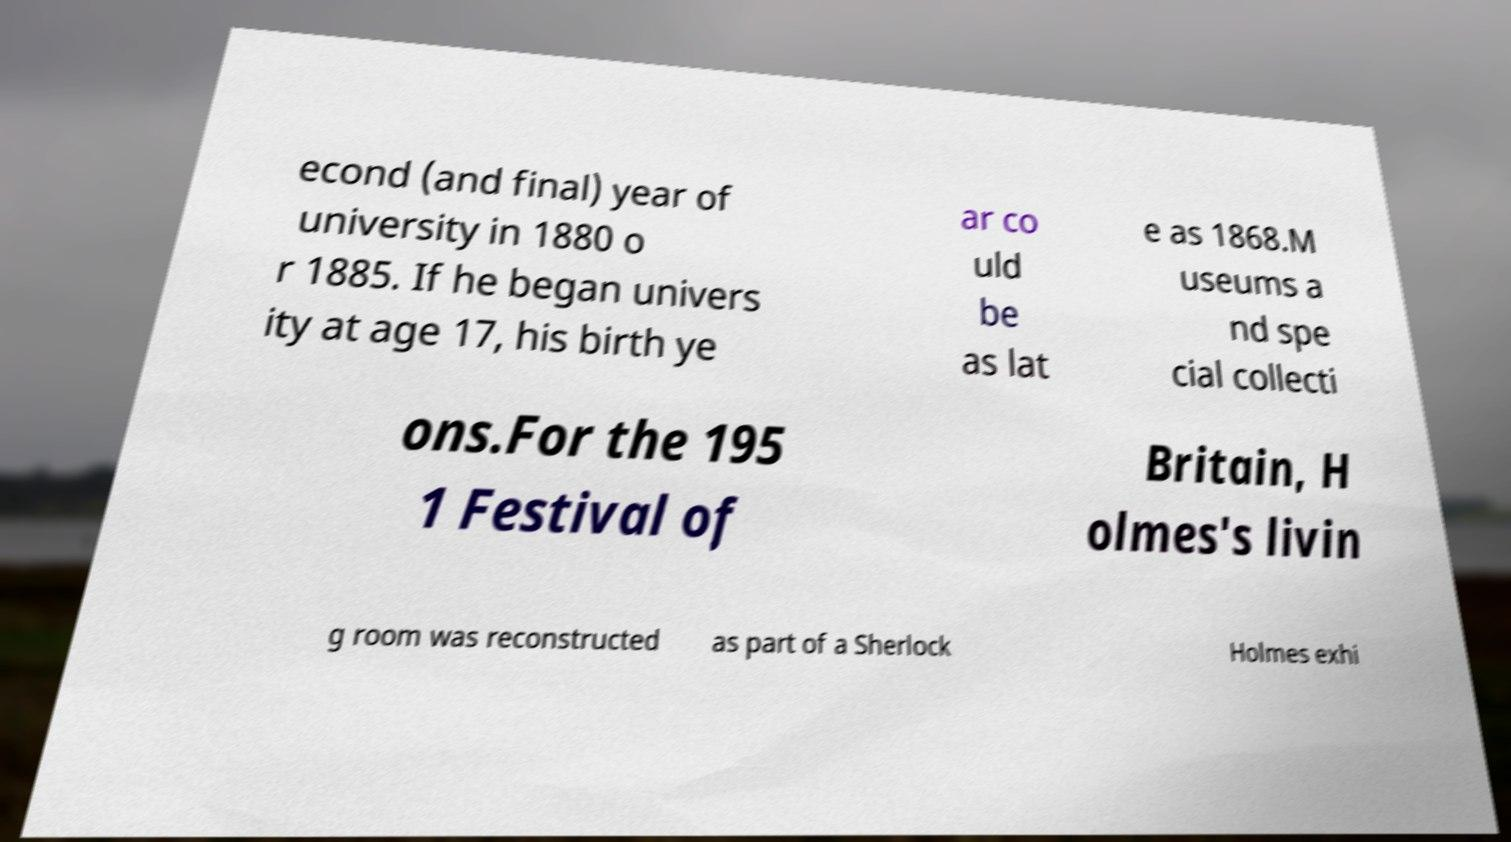For documentation purposes, I need the text within this image transcribed. Could you provide that? econd (and final) year of university in 1880 o r 1885. If he began univers ity at age 17, his birth ye ar co uld be as lat e as 1868.M useums a nd spe cial collecti ons.For the 195 1 Festival of Britain, H olmes's livin g room was reconstructed as part of a Sherlock Holmes exhi 